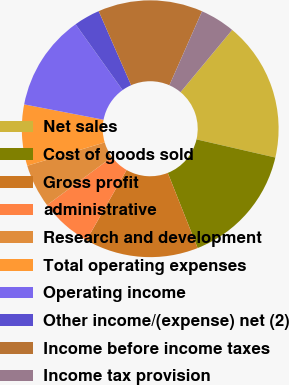Convert chart to OTSL. <chart><loc_0><loc_0><loc_500><loc_500><pie_chart><fcel>Net sales<fcel>Cost of goods sold<fcel>Gross profit<fcel>administrative<fcel>Research and development<fcel>Total operating expenses<fcel>Operating income<fcel>Other income/(expense) net (2)<fcel>Income before income taxes<fcel>Income tax provision<nl><fcel>17.58%<fcel>15.38%<fcel>14.29%<fcel>6.59%<fcel>5.49%<fcel>7.69%<fcel>12.09%<fcel>3.3%<fcel>13.19%<fcel>4.4%<nl></chart> 